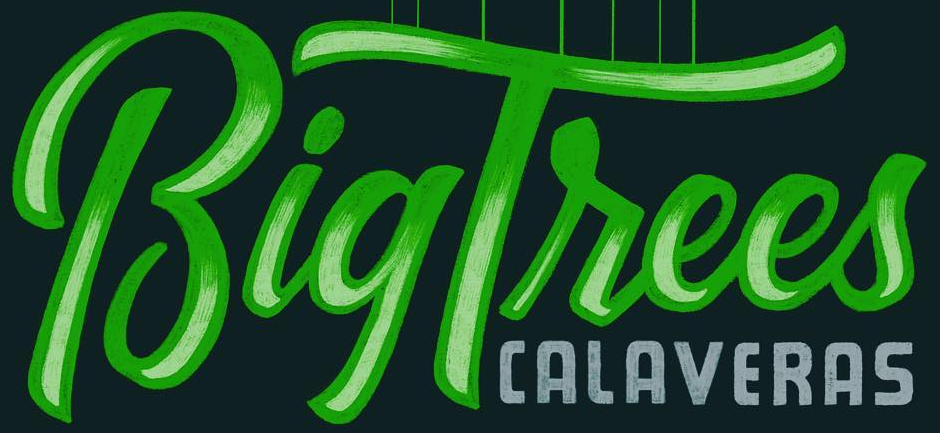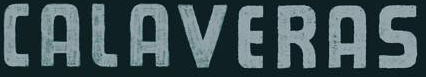Identify the words shown in these images in order, separated by a semicolon. BigTrees; CALAVERAS 